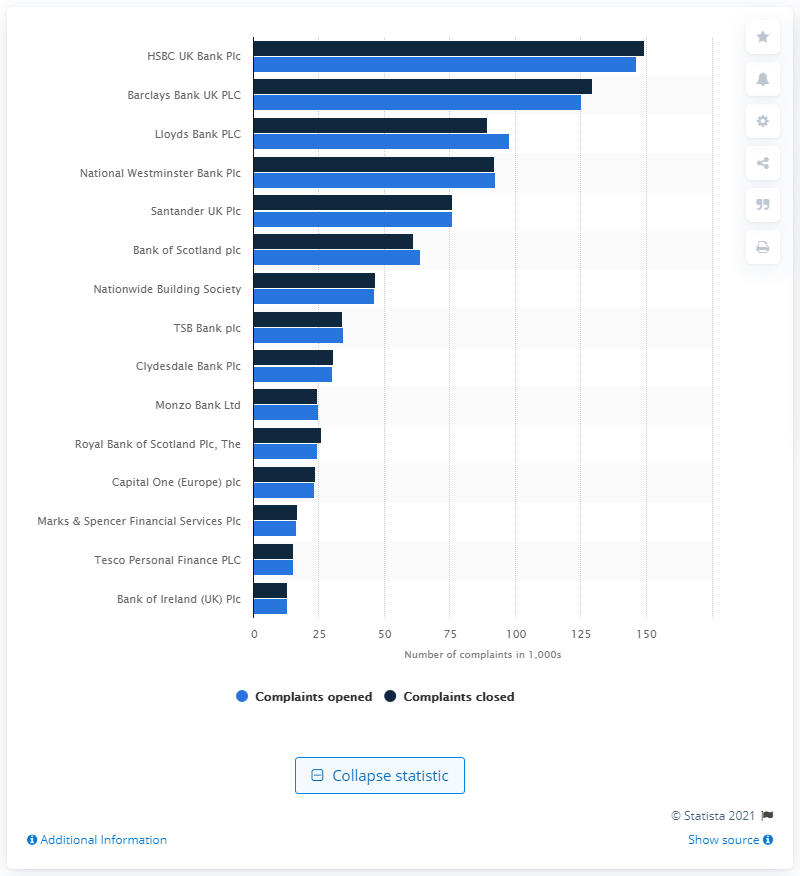Give some essential details in this illustration. During the first half of 2020, HSBC UK Bank Plc received the highest number of complaints among all banks in the United Kingdom. 